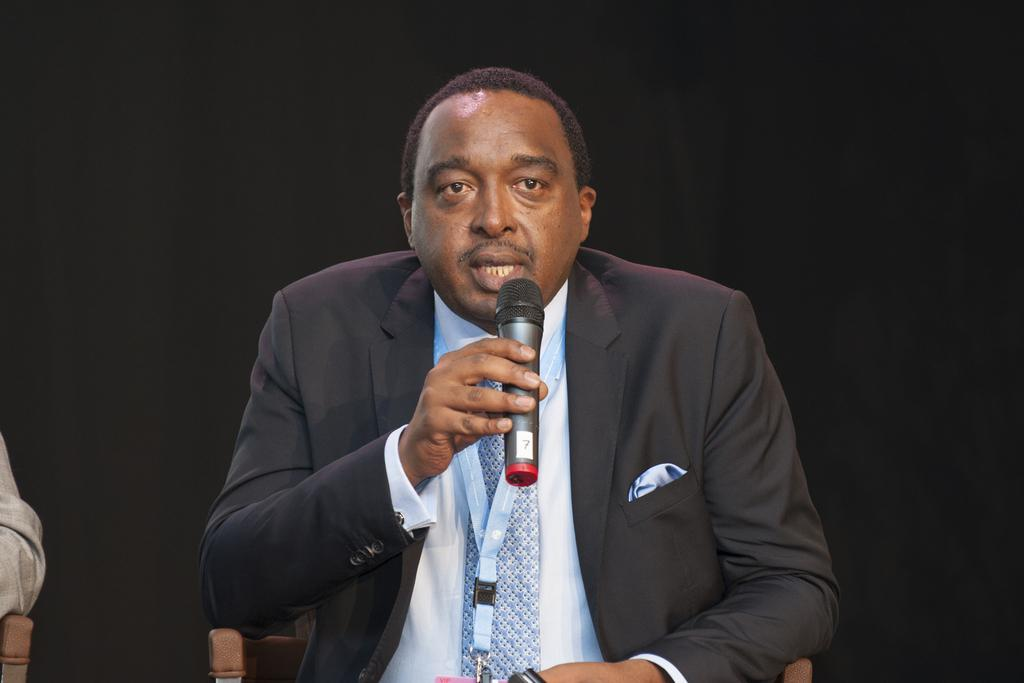Who is the main subject in the image? There is a man in the image. What is the man wearing? The man is wearing a black suit. What is the man holding in his hand? The man is holding a microphone in his hand. What is the man's position in the image? A: The man is sitting on a chair. What type of snake is crawling on the man's shoulder in the image? There is no snake present in the image; the man is wearing a black suit and holding a microphone. 